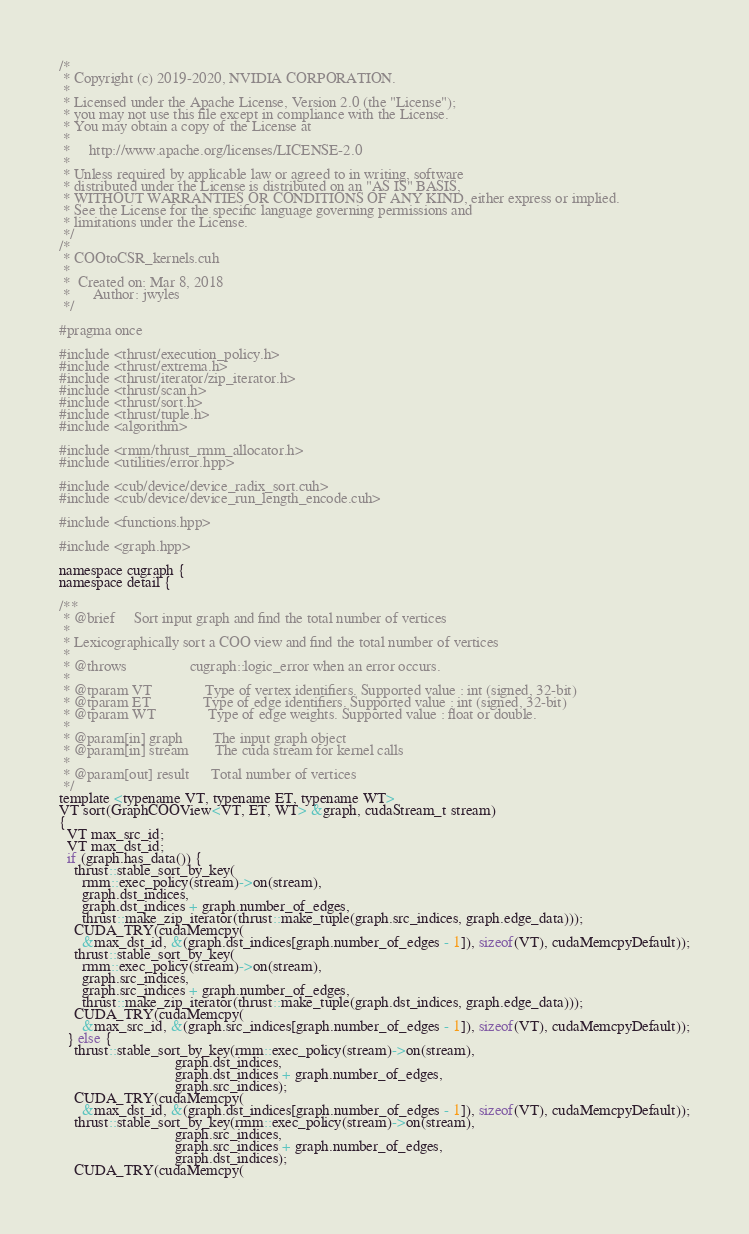<code> <loc_0><loc_0><loc_500><loc_500><_Cuda_>/*
 * Copyright (c) 2019-2020, NVIDIA CORPORATION.
 *
 * Licensed under the Apache License, Version 2.0 (the "License");
 * you may not use this file except in compliance with the License.
 * You may obtain a copy of the License at
 *
 *     http://www.apache.org/licenses/LICENSE-2.0
 *
 * Unless required by applicable law or agreed to in writing, software
 * distributed under the License is distributed on an "AS IS" BASIS,
 * WITHOUT WARRANTIES OR CONDITIONS OF ANY KIND, either express or implied.
 * See the License for the specific language governing permissions and
 * limitations under the License.
 */
/*
 * COOtoCSR_kernels.cuh
 *
 *  Created on: Mar 8, 2018
 *      Author: jwyles
 */

#pragma once

#include <thrust/execution_policy.h>
#include <thrust/extrema.h>
#include <thrust/iterator/zip_iterator.h>
#include <thrust/scan.h>
#include <thrust/sort.h>
#include <thrust/tuple.h>
#include <algorithm>

#include <rmm/thrust_rmm_allocator.h>
#include <utilities/error.hpp>

#include <cub/device/device_radix_sort.cuh>
#include <cub/device/device_run_length_encode.cuh>

#include <functions.hpp>

#include <graph.hpp>

namespace cugraph {
namespace detail {

/**
 * @brief     Sort input graph and find the total number of vertices
 *
 * Lexicographically sort a COO view and find the total number of vertices
 *
 * @throws                 cugraph::logic_error when an error occurs.
 *
 * @tparam VT              Type of vertex identifiers. Supported value : int (signed, 32-bit)
 * @tparam ET              Type of edge identifiers. Supported value : int (signed, 32-bit)
 * @tparam WT              Type of edge weights. Supported value : float or double.
 *
 * @param[in] graph        The input graph object
 * @param[in] stream       The cuda stream for kernel calls
 *
 * @param[out] result      Total number of vertices
 */
template <typename VT, typename ET, typename WT>
VT sort(GraphCOOView<VT, ET, WT> &graph, cudaStream_t stream)
{
  VT max_src_id;
  VT max_dst_id;
  if (graph.has_data()) {
    thrust::stable_sort_by_key(
      rmm::exec_policy(stream)->on(stream),
      graph.dst_indices,
      graph.dst_indices + graph.number_of_edges,
      thrust::make_zip_iterator(thrust::make_tuple(graph.src_indices, graph.edge_data)));
    CUDA_TRY(cudaMemcpy(
      &max_dst_id, &(graph.dst_indices[graph.number_of_edges - 1]), sizeof(VT), cudaMemcpyDefault));
    thrust::stable_sort_by_key(
      rmm::exec_policy(stream)->on(stream),
      graph.src_indices,
      graph.src_indices + graph.number_of_edges,
      thrust::make_zip_iterator(thrust::make_tuple(graph.dst_indices, graph.edge_data)));
    CUDA_TRY(cudaMemcpy(
      &max_src_id, &(graph.src_indices[graph.number_of_edges - 1]), sizeof(VT), cudaMemcpyDefault));
  } else {
    thrust::stable_sort_by_key(rmm::exec_policy(stream)->on(stream),
                               graph.dst_indices,
                               graph.dst_indices + graph.number_of_edges,
                               graph.src_indices);
    CUDA_TRY(cudaMemcpy(
      &max_dst_id, &(graph.dst_indices[graph.number_of_edges - 1]), sizeof(VT), cudaMemcpyDefault));
    thrust::stable_sort_by_key(rmm::exec_policy(stream)->on(stream),
                               graph.src_indices,
                               graph.src_indices + graph.number_of_edges,
                               graph.dst_indices);
    CUDA_TRY(cudaMemcpy(</code> 